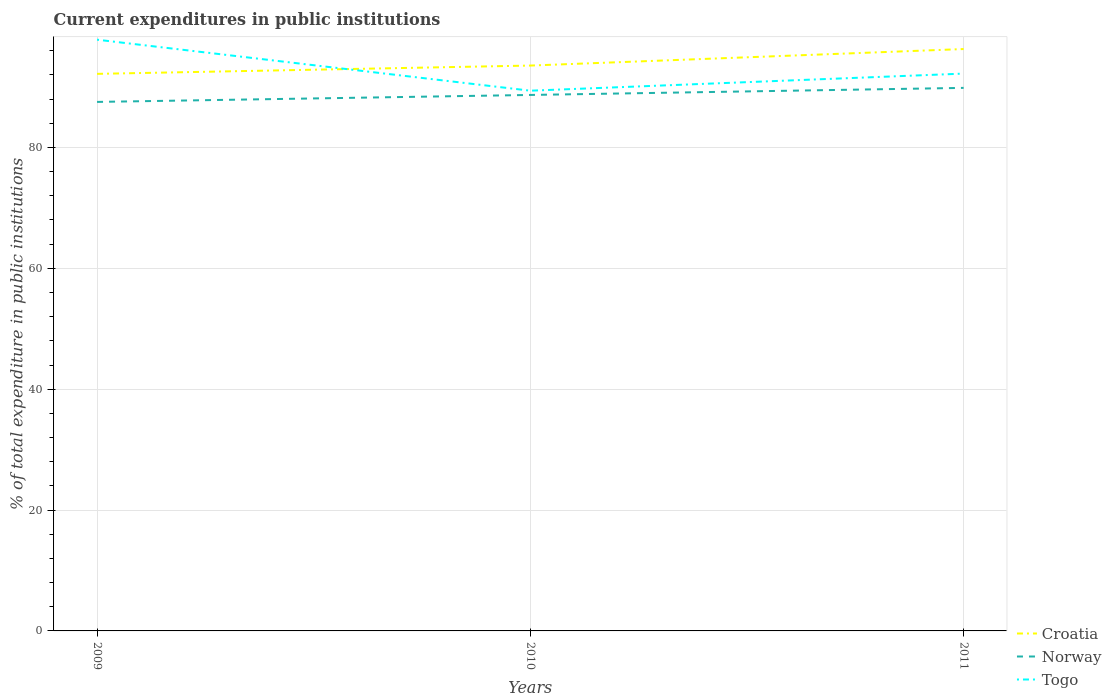How many different coloured lines are there?
Your answer should be very brief. 3. Across all years, what is the maximum current expenditures in public institutions in Togo?
Make the answer very short. 89.39. In which year was the current expenditures in public institutions in Norway maximum?
Provide a short and direct response. 2009. What is the total current expenditures in public institutions in Croatia in the graph?
Make the answer very short. -4.11. What is the difference between the highest and the second highest current expenditures in public institutions in Norway?
Your response must be concise. 2.32. Is the current expenditures in public institutions in Croatia strictly greater than the current expenditures in public institutions in Togo over the years?
Offer a very short reply. No. What is the difference between two consecutive major ticks on the Y-axis?
Your answer should be very brief. 20. Does the graph contain grids?
Make the answer very short. Yes. How many legend labels are there?
Offer a terse response. 3. What is the title of the graph?
Your answer should be compact. Current expenditures in public institutions. What is the label or title of the Y-axis?
Make the answer very short. % of total expenditure in public institutions. What is the % of total expenditure in public institutions of Croatia in 2009?
Give a very brief answer. 92.18. What is the % of total expenditure in public institutions in Norway in 2009?
Make the answer very short. 87.53. What is the % of total expenditure in public institutions in Togo in 2009?
Your answer should be very brief. 97.83. What is the % of total expenditure in public institutions in Croatia in 2010?
Keep it short and to the point. 93.55. What is the % of total expenditure in public institutions of Norway in 2010?
Make the answer very short. 88.69. What is the % of total expenditure in public institutions of Togo in 2010?
Give a very brief answer. 89.39. What is the % of total expenditure in public institutions of Croatia in 2011?
Ensure brevity in your answer.  96.29. What is the % of total expenditure in public institutions of Norway in 2011?
Your response must be concise. 89.86. What is the % of total expenditure in public institutions of Togo in 2011?
Your answer should be compact. 92.22. Across all years, what is the maximum % of total expenditure in public institutions of Croatia?
Give a very brief answer. 96.29. Across all years, what is the maximum % of total expenditure in public institutions of Norway?
Your answer should be compact. 89.86. Across all years, what is the maximum % of total expenditure in public institutions of Togo?
Offer a very short reply. 97.83. Across all years, what is the minimum % of total expenditure in public institutions of Croatia?
Provide a short and direct response. 92.18. Across all years, what is the minimum % of total expenditure in public institutions in Norway?
Provide a succinct answer. 87.53. Across all years, what is the minimum % of total expenditure in public institutions in Togo?
Ensure brevity in your answer.  89.39. What is the total % of total expenditure in public institutions in Croatia in the graph?
Your answer should be very brief. 282.02. What is the total % of total expenditure in public institutions of Norway in the graph?
Provide a succinct answer. 266.08. What is the total % of total expenditure in public institutions of Togo in the graph?
Offer a terse response. 279.44. What is the difference between the % of total expenditure in public institutions of Croatia in 2009 and that in 2010?
Your answer should be compact. -1.37. What is the difference between the % of total expenditure in public institutions in Norway in 2009 and that in 2010?
Offer a very short reply. -1.15. What is the difference between the % of total expenditure in public institutions of Togo in 2009 and that in 2010?
Offer a terse response. 8.44. What is the difference between the % of total expenditure in public institutions in Croatia in 2009 and that in 2011?
Provide a short and direct response. -4.11. What is the difference between the % of total expenditure in public institutions in Norway in 2009 and that in 2011?
Give a very brief answer. -2.32. What is the difference between the % of total expenditure in public institutions of Togo in 2009 and that in 2011?
Keep it short and to the point. 5.61. What is the difference between the % of total expenditure in public institutions of Croatia in 2010 and that in 2011?
Provide a short and direct response. -2.73. What is the difference between the % of total expenditure in public institutions in Norway in 2010 and that in 2011?
Ensure brevity in your answer.  -1.17. What is the difference between the % of total expenditure in public institutions of Togo in 2010 and that in 2011?
Provide a succinct answer. -2.83. What is the difference between the % of total expenditure in public institutions in Croatia in 2009 and the % of total expenditure in public institutions in Norway in 2010?
Offer a very short reply. 3.49. What is the difference between the % of total expenditure in public institutions in Croatia in 2009 and the % of total expenditure in public institutions in Togo in 2010?
Give a very brief answer. 2.79. What is the difference between the % of total expenditure in public institutions of Norway in 2009 and the % of total expenditure in public institutions of Togo in 2010?
Keep it short and to the point. -1.86. What is the difference between the % of total expenditure in public institutions of Croatia in 2009 and the % of total expenditure in public institutions of Norway in 2011?
Keep it short and to the point. 2.32. What is the difference between the % of total expenditure in public institutions of Croatia in 2009 and the % of total expenditure in public institutions of Togo in 2011?
Provide a short and direct response. -0.04. What is the difference between the % of total expenditure in public institutions in Norway in 2009 and the % of total expenditure in public institutions in Togo in 2011?
Your response must be concise. -4.69. What is the difference between the % of total expenditure in public institutions of Croatia in 2010 and the % of total expenditure in public institutions of Norway in 2011?
Give a very brief answer. 3.69. What is the difference between the % of total expenditure in public institutions of Croatia in 2010 and the % of total expenditure in public institutions of Togo in 2011?
Provide a succinct answer. 1.33. What is the difference between the % of total expenditure in public institutions in Norway in 2010 and the % of total expenditure in public institutions in Togo in 2011?
Your response must be concise. -3.53. What is the average % of total expenditure in public institutions in Croatia per year?
Ensure brevity in your answer.  94. What is the average % of total expenditure in public institutions in Norway per year?
Your answer should be very brief. 88.69. What is the average % of total expenditure in public institutions in Togo per year?
Offer a terse response. 93.15. In the year 2009, what is the difference between the % of total expenditure in public institutions of Croatia and % of total expenditure in public institutions of Norway?
Your answer should be compact. 4.64. In the year 2009, what is the difference between the % of total expenditure in public institutions of Croatia and % of total expenditure in public institutions of Togo?
Your answer should be very brief. -5.65. In the year 2009, what is the difference between the % of total expenditure in public institutions in Norway and % of total expenditure in public institutions in Togo?
Your response must be concise. -10.3. In the year 2010, what is the difference between the % of total expenditure in public institutions in Croatia and % of total expenditure in public institutions in Norway?
Keep it short and to the point. 4.86. In the year 2010, what is the difference between the % of total expenditure in public institutions of Croatia and % of total expenditure in public institutions of Togo?
Your answer should be compact. 4.16. In the year 2010, what is the difference between the % of total expenditure in public institutions of Norway and % of total expenditure in public institutions of Togo?
Make the answer very short. -0.7. In the year 2011, what is the difference between the % of total expenditure in public institutions of Croatia and % of total expenditure in public institutions of Norway?
Provide a succinct answer. 6.43. In the year 2011, what is the difference between the % of total expenditure in public institutions of Croatia and % of total expenditure in public institutions of Togo?
Make the answer very short. 4.06. In the year 2011, what is the difference between the % of total expenditure in public institutions in Norway and % of total expenditure in public institutions in Togo?
Provide a succinct answer. -2.36. What is the ratio of the % of total expenditure in public institutions in Norway in 2009 to that in 2010?
Give a very brief answer. 0.99. What is the ratio of the % of total expenditure in public institutions in Togo in 2009 to that in 2010?
Your answer should be compact. 1.09. What is the ratio of the % of total expenditure in public institutions in Croatia in 2009 to that in 2011?
Make the answer very short. 0.96. What is the ratio of the % of total expenditure in public institutions in Norway in 2009 to that in 2011?
Your response must be concise. 0.97. What is the ratio of the % of total expenditure in public institutions in Togo in 2009 to that in 2011?
Ensure brevity in your answer.  1.06. What is the ratio of the % of total expenditure in public institutions in Croatia in 2010 to that in 2011?
Your response must be concise. 0.97. What is the ratio of the % of total expenditure in public institutions in Togo in 2010 to that in 2011?
Keep it short and to the point. 0.97. What is the difference between the highest and the second highest % of total expenditure in public institutions of Croatia?
Give a very brief answer. 2.73. What is the difference between the highest and the second highest % of total expenditure in public institutions of Norway?
Provide a succinct answer. 1.17. What is the difference between the highest and the second highest % of total expenditure in public institutions of Togo?
Your response must be concise. 5.61. What is the difference between the highest and the lowest % of total expenditure in public institutions of Croatia?
Make the answer very short. 4.11. What is the difference between the highest and the lowest % of total expenditure in public institutions in Norway?
Keep it short and to the point. 2.32. What is the difference between the highest and the lowest % of total expenditure in public institutions in Togo?
Offer a terse response. 8.44. 